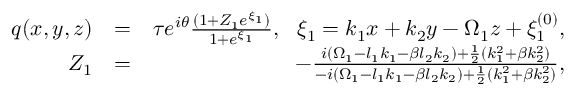Convert formula to latex. <formula><loc_0><loc_0><loc_500><loc_500>\begin{array} { r l r } { q ( x , y , z ) } & { = } & { \tau e ^ { i \theta } \frac { ( 1 + Z _ { 1 } e ^ { \xi _ { 1 } } ) } { 1 + e ^ { \xi _ { 1 } } } , \xi _ { 1 } = k _ { 1 } x + k _ { 2 } y - \Omega _ { 1 } z + \xi _ { 1 } ^ { ( 0 ) } , } \\ { Z _ { 1 } } & { = } & { - \frac { i ( \Omega _ { 1 } - l _ { 1 } k _ { 1 } - \beta l _ { 2 } k _ { 2 } ) + \frac { 1 } { 2 } ( k _ { 1 } ^ { 2 } + \beta k _ { 2 } ^ { 2 } ) } { - i ( \Omega _ { 1 } - l _ { 1 } k _ { 1 } - \beta l _ { 2 } k _ { 2 } ) + \frac { 1 } { 2 } ( k _ { 1 } ^ { 2 } + \beta k _ { 2 } ^ { 2 } ) } , } \end{array}</formula> 